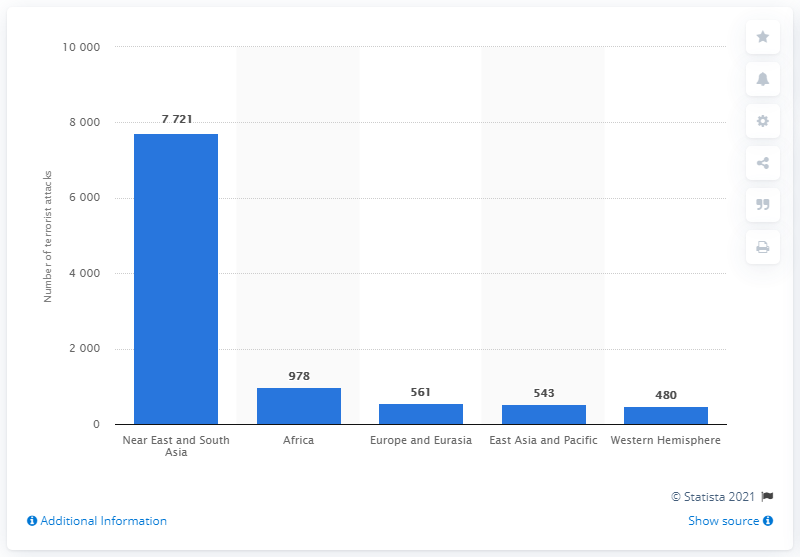Specify some key components in this picture. In 2011, a total of 978 terrorist attacks were registered in Africa. 